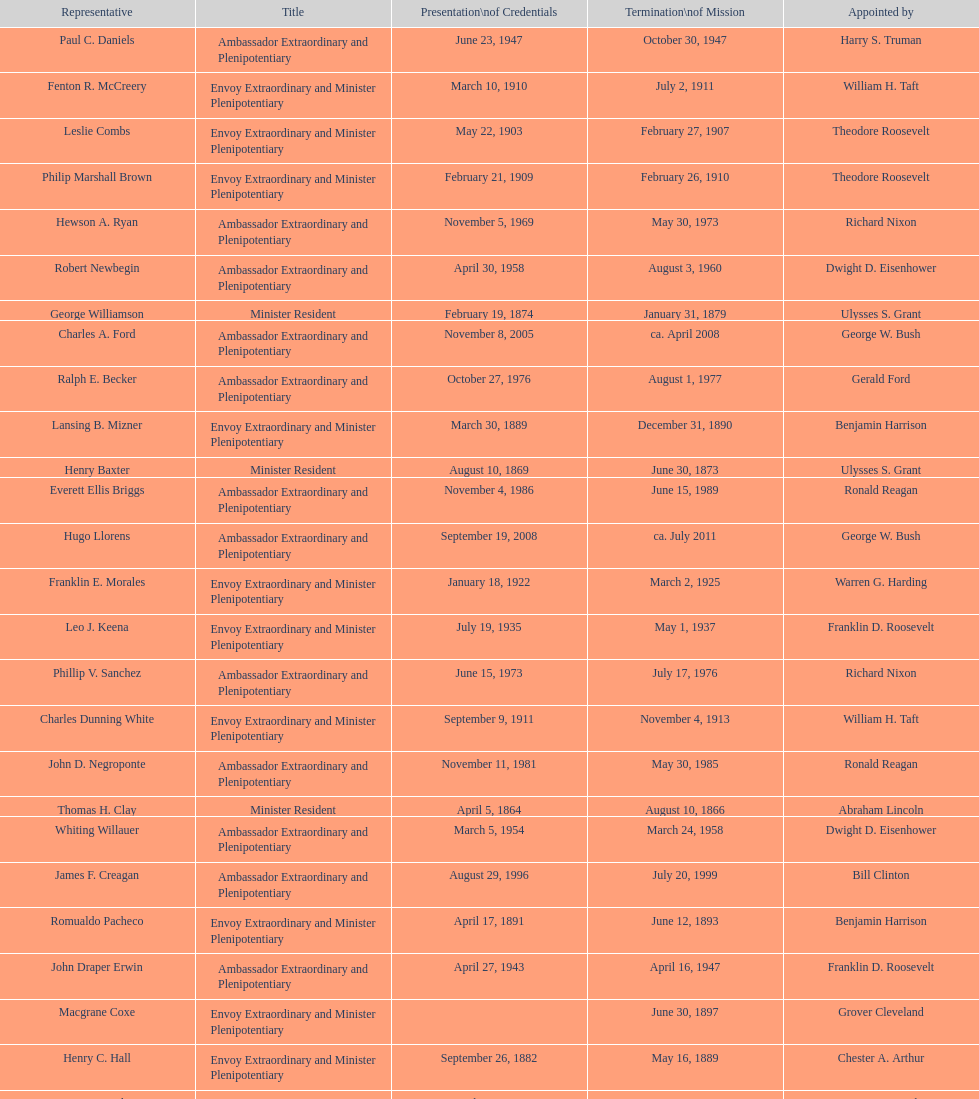Can you parse all the data within this table? {'header': ['Representative', 'Title', 'Presentation\\nof Credentials', 'Termination\\nof Mission', 'Appointed by'], 'rows': [['Paul C. Daniels', 'Ambassador Extraordinary and Plenipotentiary', 'June 23, 1947', 'October 30, 1947', 'Harry S. Truman'], ['Fenton R. McCreery', 'Envoy Extraordinary and Minister Plenipotentiary', 'March 10, 1910', 'July 2, 1911', 'William H. Taft'], ['Leslie Combs', 'Envoy Extraordinary and Minister Plenipotentiary', 'May 22, 1903', 'February 27, 1907', 'Theodore Roosevelt'], ['Philip Marshall Brown', 'Envoy Extraordinary and Minister Plenipotentiary', 'February 21, 1909', 'February 26, 1910', 'Theodore Roosevelt'], ['Hewson A. Ryan', 'Ambassador Extraordinary and Plenipotentiary', 'November 5, 1969', 'May 30, 1973', 'Richard Nixon'], ['Robert Newbegin', 'Ambassador Extraordinary and Plenipotentiary', 'April 30, 1958', 'August 3, 1960', 'Dwight D. Eisenhower'], ['George Williamson', 'Minister Resident', 'February 19, 1874', 'January 31, 1879', 'Ulysses S. Grant'], ['Charles A. Ford', 'Ambassador Extraordinary and Plenipotentiary', 'November 8, 2005', 'ca. April 2008', 'George W. Bush'], ['Ralph E. Becker', 'Ambassador Extraordinary and Plenipotentiary', 'October 27, 1976', 'August 1, 1977', 'Gerald Ford'], ['Lansing B. Mizner', 'Envoy Extraordinary and Minister Plenipotentiary', 'March 30, 1889', 'December 31, 1890', 'Benjamin Harrison'], ['Henry Baxter', 'Minister Resident', 'August 10, 1869', 'June 30, 1873', 'Ulysses S. Grant'], ['Everett Ellis Briggs', 'Ambassador Extraordinary and Plenipotentiary', 'November 4, 1986', 'June 15, 1989', 'Ronald Reagan'], ['Hugo Llorens', 'Ambassador Extraordinary and Plenipotentiary', 'September 19, 2008', 'ca. July 2011', 'George W. Bush'], ['Franklin E. Morales', 'Envoy Extraordinary and Minister Plenipotentiary', 'January 18, 1922', 'March 2, 1925', 'Warren G. Harding'], ['Leo J. Keena', 'Envoy Extraordinary and Minister Plenipotentiary', 'July 19, 1935', 'May 1, 1937', 'Franklin D. Roosevelt'], ['Phillip V. Sanchez', 'Ambassador Extraordinary and Plenipotentiary', 'June 15, 1973', 'July 17, 1976', 'Richard Nixon'], ['Charles Dunning White', 'Envoy Extraordinary and Minister Plenipotentiary', 'September 9, 1911', 'November 4, 1913', 'William H. Taft'], ['John D. Negroponte', 'Ambassador Extraordinary and Plenipotentiary', 'November 11, 1981', 'May 30, 1985', 'Ronald Reagan'], ['Thomas H. Clay', 'Minister Resident', 'April 5, 1864', 'August 10, 1866', 'Abraham Lincoln'], ['Whiting Willauer', 'Ambassador Extraordinary and Plenipotentiary', 'March 5, 1954', 'March 24, 1958', 'Dwight D. Eisenhower'], ['James F. Creagan', 'Ambassador Extraordinary and Plenipotentiary', 'August 29, 1996', 'July 20, 1999', 'Bill Clinton'], ['Romualdo Pacheco', 'Envoy Extraordinary and Minister Plenipotentiary', 'April 17, 1891', 'June 12, 1893', 'Benjamin Harrison'], ['John Draper Erwin', 'Ambassador Extraordinary and Plenipotentiary', 'April 27, 1943', 'April 16, 1947', 'Franklin D. Roosevelt'], ['Macgrane Coxe', 'Envoy Extraordinary and Minister Plenipotentiary', '', 'June 30, 1897', 'Grover Cleveland'], ['Henry C. Hall', 'Envoy Extraordinary and Minister Plenipotentiary', 'September 26, 1882', 'May 16, 1889', 'Chester A. Arthur'], ['Larry Leon Palmer', 'Ambassador Extraordinary and Plenipotentiary', 'October 8, 2002', 'May 7, 2005', 'George W. Bush'], ['Herbert S. Bursley', 'Ambassador Extraordinary and Plenipotentiary', 'May 15, 1948', 'December 12, 1950', 'Harry S. Truman'], ['John Draper Erwin', 'Envoy Extraordinary and Minister Plenipotentiary', 'September 8, 1937', 'April 27, 1943', 'Franklin D. Roosevelt'], ['George T. Summerlin', 'Envoy Extraordinary and Minister Plenipotentiary', 'November 21, 1925', 'December 17, 1929', 'Calvin Coolidge'], ['John Ewing', 'Envoy Extraordinary and Minister Plenipotentiary', 'December 26, 1913', 'January 18, 1918', 'Woodrow Wilson'], ['Beverly L. Clarke', 'Minister Resident', 'August 10, 1858', 'March 17, 1860', 'James Buchanan'], ['Solon Borland', 'Envoy Extraordinary and Minister Plenipotentiary', '', 'April 17, 1854', 'Franklin Pierce'], ['Joseph J. Jova', 'Ambassador Extraordinary and Plenipotentiary', 'July 12, 1965', 'June 21, 1969', 'Lyndon B. Johnson'], ['Mari-Luci Jaramillo', 'Ambassador Extraordinary and Plenipotentiary', 'October 27, 1977', 'September 19, 1980', 'Jimmy Carter'], ['Lisa Kubiske', 'Ambassador Extraordinary and Plenipotentiary', 'July 26, 2011', 'Incumbent', 'Barack Obama'], ['Cresencio S. Arcos, Jr.', 'Ambassador Extraordinary and Plenipotentiary', 'January 29, 1990', 'July 1, 1993', 'George H. W. Bush'], ['Richard H. Rousseau', 'Minister Resident', 'October 10, 1866', 'August 10, 1869', 'Andrew Johnson'], ['Henry C. Hall', 'Minister Resident', 'April 21, 1882', 'September 26, 1882', 'Chester A. Arthur'], ['Jack R. Binns', 'Ambassador Extraordinary and Plenipotentiary', 'October 10, 1980', 'October 31, 1981', 'Jimmy Carter'], ['Frank Almaguer', 'Ambassador Extraordinary and Plenipotentiary', 'August 25, 1999', 'September 5, 2002', 'Bill Clinton'], ['Julius G. Lay', 'Envoy Extraordinary and Minister Plenipotentiary', 'May 31, 1930', 'March 17, 1935', 'Herbert Hoover'], ['James R. Partridge', 'Minister Resident', 'April 25, 1862', 'November 14, 1862', 'Abraham Lincoln'], ['Cornelius A. Logan', 'Minister Resident', 'October 10, 1879', 'April 15, 1882', 'Rutherford B. Hayes'], ['W. Godfrey Hunter', 'Envoy Extraordinary and Minister Plenipotentiary', 'January 19, 1899', 'February 2, 1903', 'William McKinley'], ['John Arthur Ferch', 'Ambassador Extraordinary and Plenipotentiary', 'August 22, 1985', 'July 9, 1986', 'Ronald Reagan'], ['H. Percival Dodge', 'Envoy Extraordinary and Minister Plenipotentiary', 'June 17, 1908', 'February 6, 1909', 'Theodore Roosevelt'], ['Charles R. Burrows', 'Ambassador Extraordinary and Plenipotentiary', 'November 3, 1960', 'June 28, 1965', 'Dwight D. Eisenhower'], ['John Draper Erwin', 'Ambassador Extraordinary and Plenipotentiary', 'March 14, 1951', 'February 28, 1954', 'Harry S. Truman'], ['Joseph W. J. Lee', 'Envoy Extraordinary and Minister Plenipotentiary', '', 'July 1, 1907', 'Theodore Roosevelt'], ['T. Sambola Jones', 'Envoy Extraordinary and Minister Plenipotentiary', 'October 2, 1918', 'October 17, 1919', 'Woodrow Wilson'], ['William Thornton Pryce', 'Ambassador Extraordinary and Plenipotentiary', 'July 21, 1993', 'August 15, 1996', 'Bill Clinton'], ['Pierce M. B. Young', 'Envoy Extraordinary and Minister Plenipotentiary', 'November 12, 1893', 'May 23, 1896', 'Grover Cleveland']]} Which ambassador to honduras served the longest term? Henry C. Hall. 